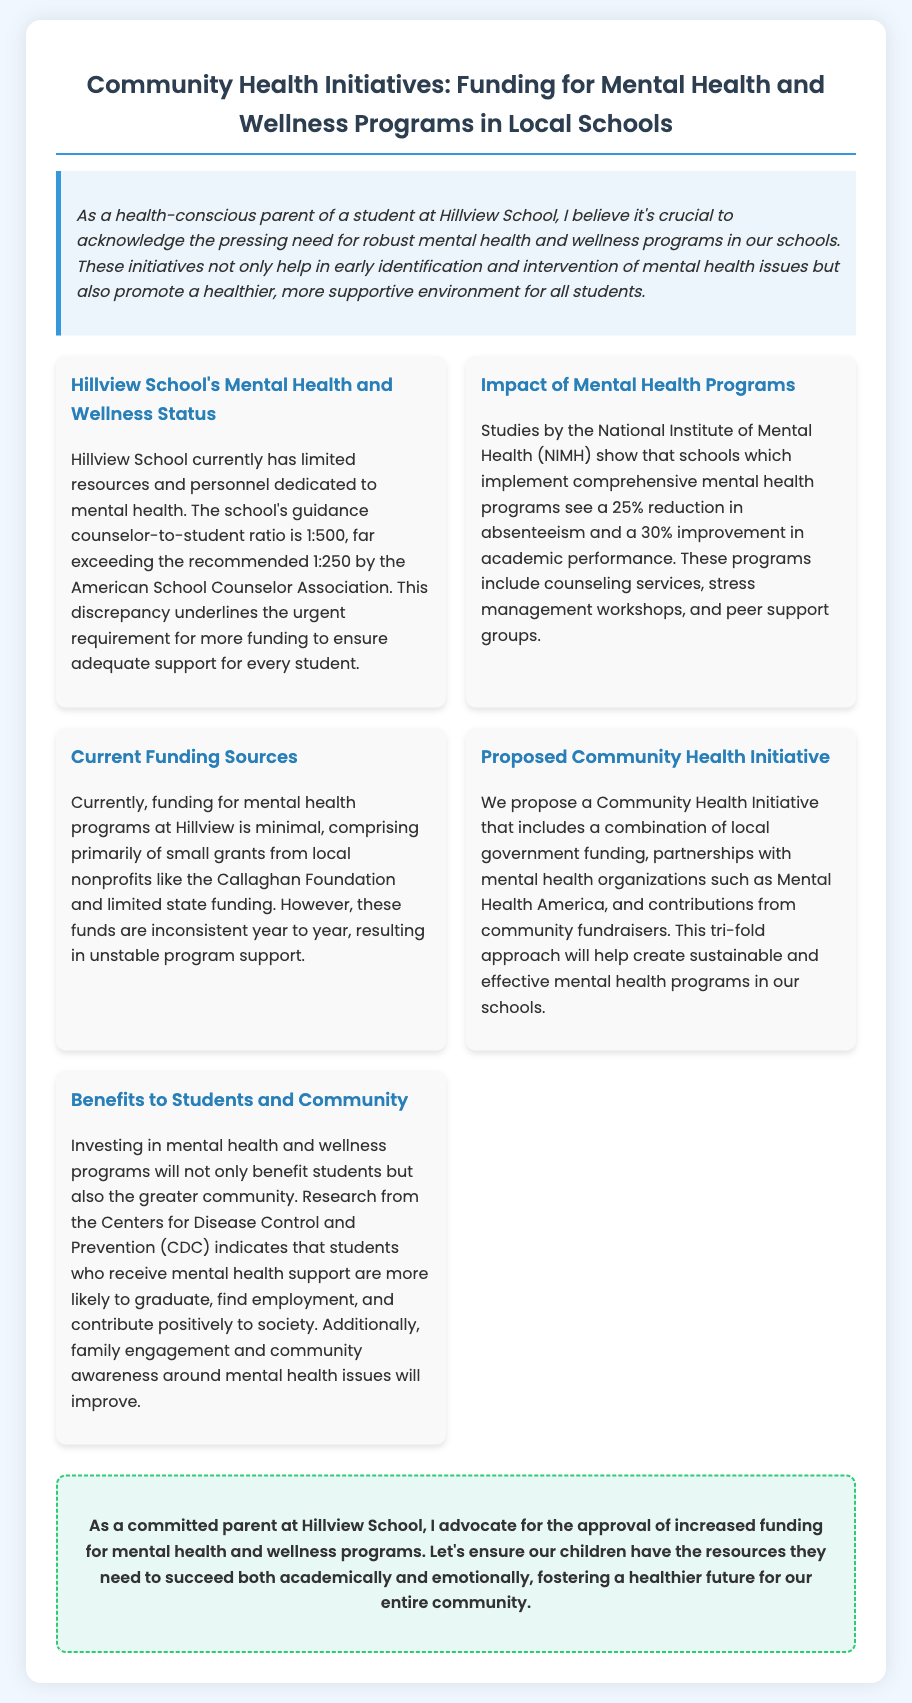What is the guidance counselor-to-student ratio at Hillview School? The document states that the guidance counselor-to-student ratio is 1:500.
Answer: 1:500 What is the recommended guidance counselor-to-student ratio by the American School Counselor Association? The document mentions that the recommended ratio is 1:250.
Answer: 1:250 What percentage reduction in absenteeism is associated with comprehensive mental health programs? The document cites a 25% reduction in absenteeism in schools with such programs.
Answer: 25% Who are the current primary funders for mental health programs at Hillview School? The text indicates that funding primarily comes from local nonprofits like the Callaghan Foundation and limited state funding.
Answer: Callaghan Foundation What is the proposed source of funding for the Community Health Initiative? The proposed source includes local government funding, partnerships with mental health organizations, and community fundraisers.
Answer: Local government funding How much improvement in academic performance is associated with mental health programs? The document indicates that there is a 30% improvement in academic performance with these programs.
Answer: 30% What organization is mentioned as a potential partner for the proposed initiative? The document lists Mental Health America as a partnering organization.
Answer: Mental Health America What is one expected benefit to the community from investing in mental health programs? The document notes that students who receive mental health support are more likely to contribute positively to society.
Answer: Contribute positively to society What is the main advocacy stance of the author as a parent? The author advocates for increased funding for mental health and wellness programs.
Answer: Increased funding for mental health programs 